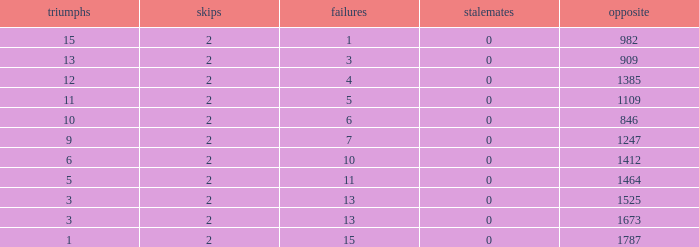What is the highest number listed under against when there were less than 3 wins and less than 15 losses? None. 